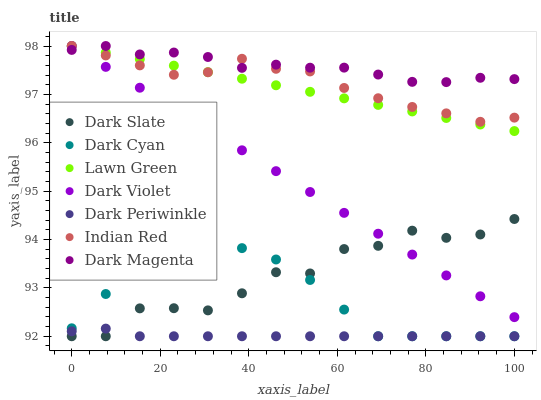Does Dark Periwinkle have the minimum area under the curve?
Answer yes or no. Yes. Does Dark Magenta have the maximum area under the curve?
Answer yes or no. Yes. Does Dark Violet have the minimum area under the curve?
Answer yes or no. No. Does Dark Violet have the maximum area under the curve?
Answer yes or no. No. Is Lawn Green the smoothest?
Answer yes or no. Yes. Is Dark Slate the roughest?
Answer yes or no. Yes. Is Dark Magenta the smoothest?
Answer yes or no. No. Is Dark Magenta the roughest?
Answer yes or no. No. Does Dark Slate have the lowest value?
Answer yes or no. Yes. Does Dark Violet have the lowest value?
Answer yes or no. No. Does Indian Red have the highest value?
Answer yes or no. Yes. Does Dark Slate have the highest value?
Answer yes or no. No. Is Dark Slate less than Dark Magenta?
Answer yes or no. Yes. Is Dark Violet greater than Dark Periwinkle?
Answer yes or no. Yes. Does Dark Cyan intersect Dark Periwinkle?
Answer yes or no. Yes. Is Dark Cyan less than Dark Periwinkle?
Answer yes or no. No. Is Dark Cyan greater than Dark Periwinkle?
Answer yes or no. No. Does Dark Slate intersect Dark Magenta?
Answer yes or no. No. 